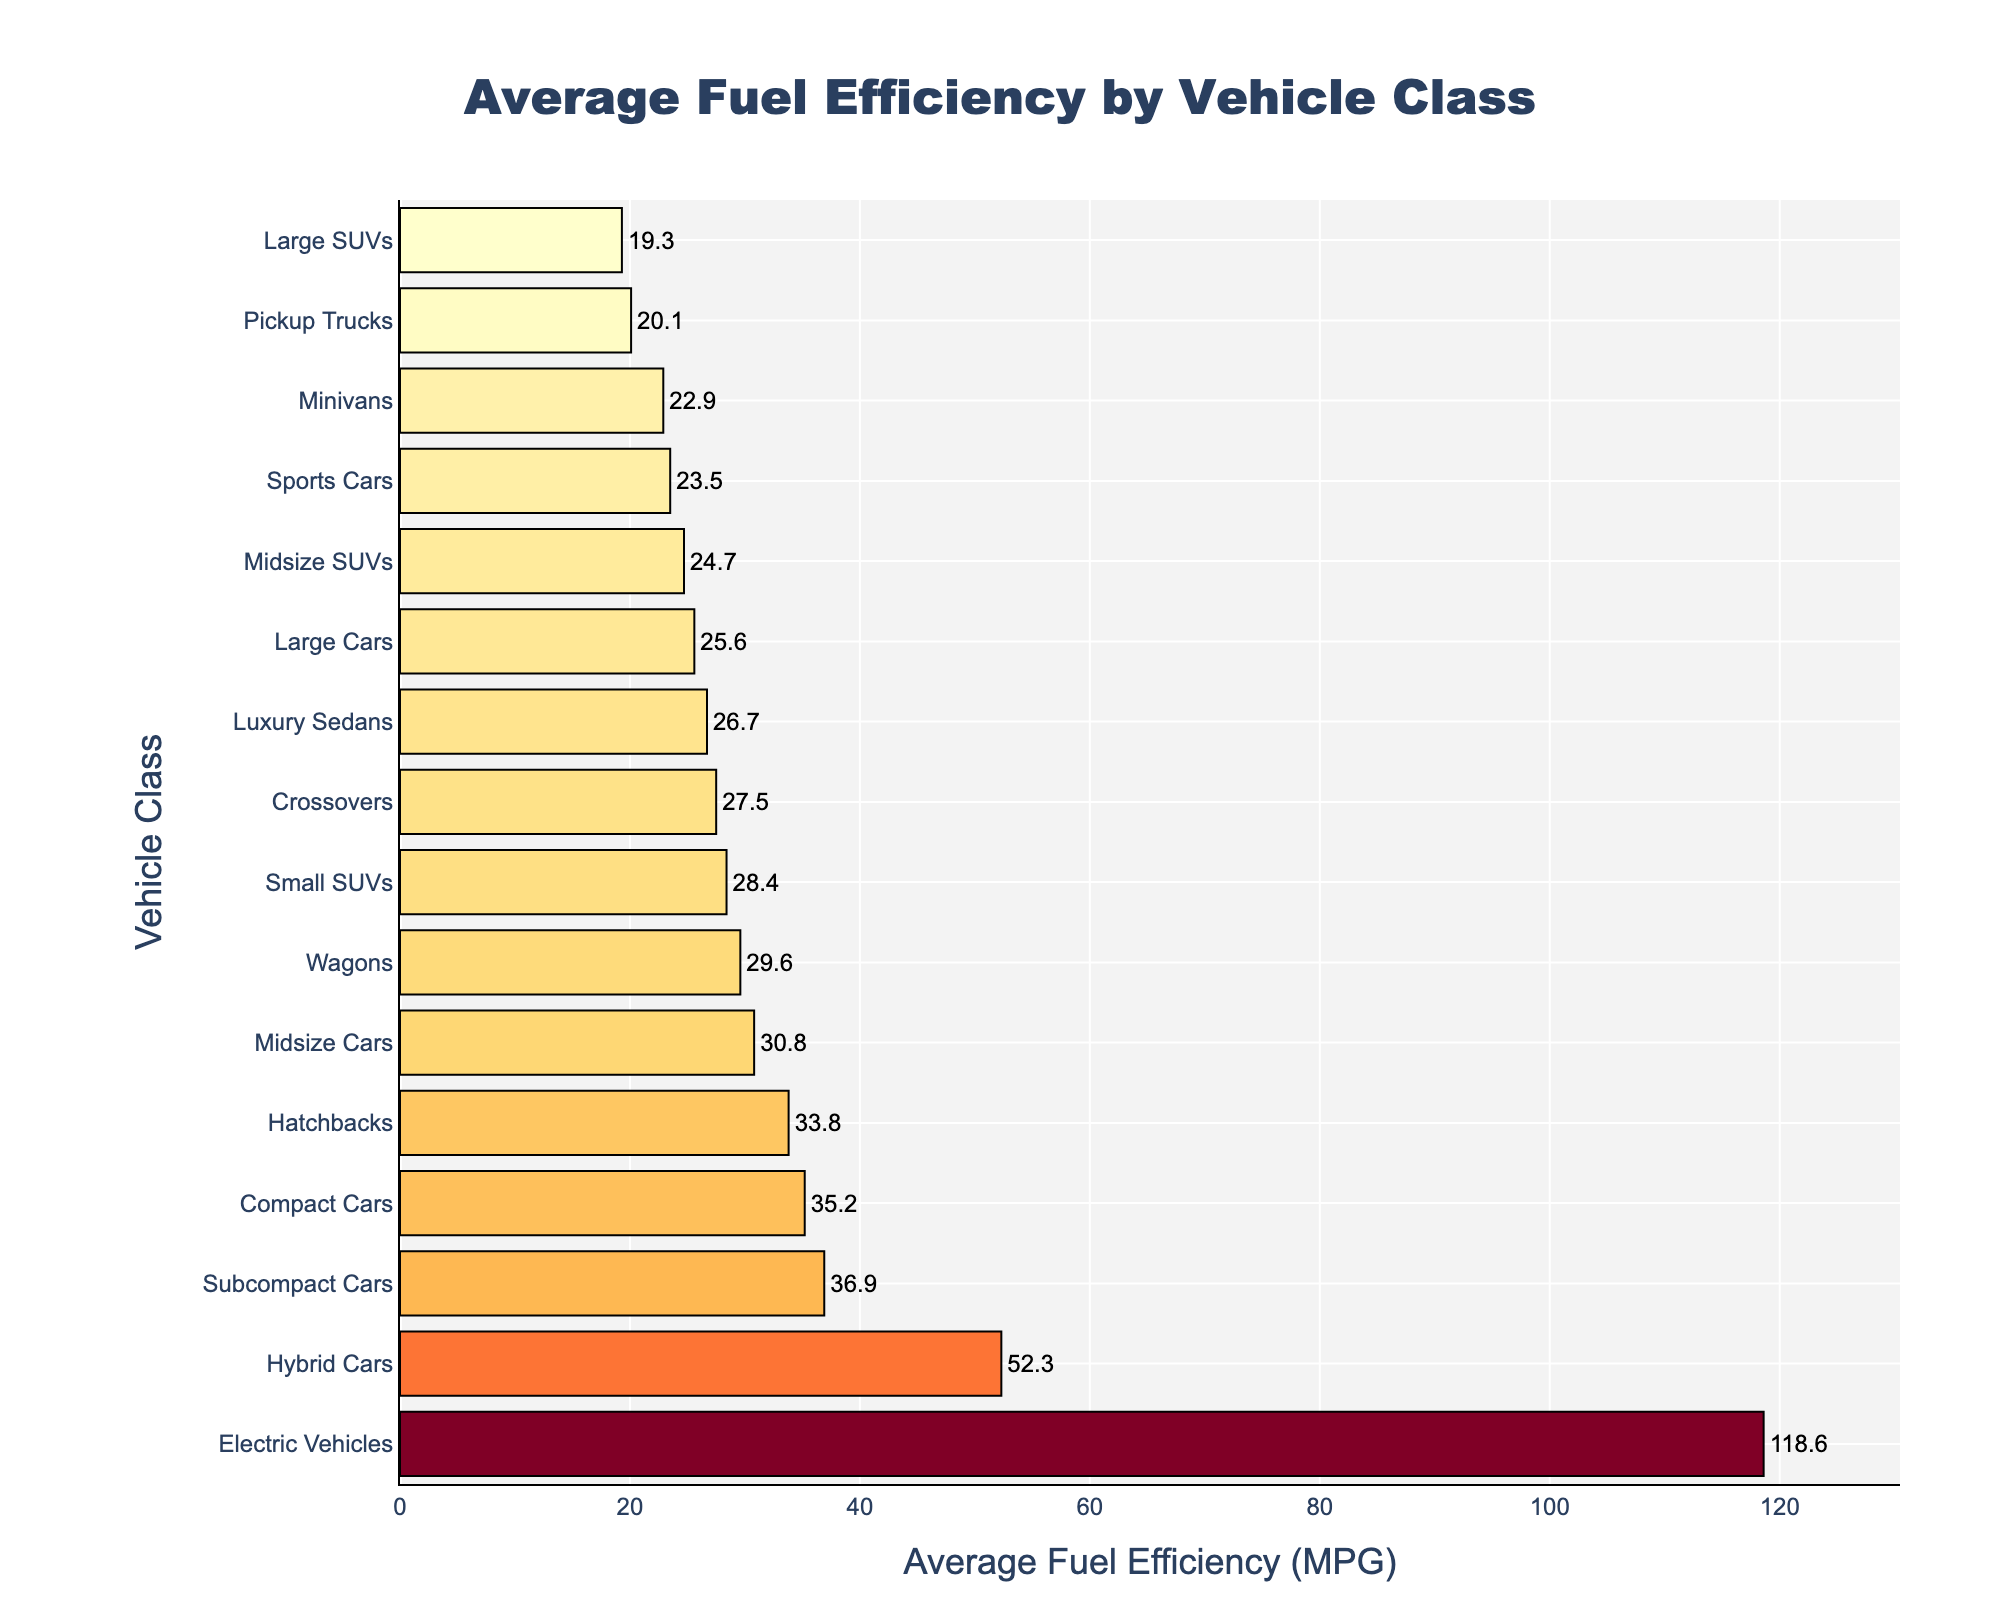Which vehicle class has the highest average fuel efficiency? The highest bar in the figure corresponds to Electric Vehicles, which visually represent the highest fuel efficiency.
Answer: Electric Vehicles How much more fuel-efficient are Compact Cars compared to Pickup Trucks? The bar lengths show Compact Cars at 35.2 MPG and Pickup Trucks at 20.1 MPG. The difference is 35.2 - 20.1 = 15.1 MPG.
Answer: 15.1 MPG Which has better fuel efficiency: Midsize Cars or Small SUVs? Comparing the bar lengths for Midsize Cars (30.8 MPG) and Small SUVs (28.4 MPG), Midsize Cars have better fuel efficiency.
Answer: Midsize Cars What is the average fuel efficiency for the classes with lower efficiency than Crossovers? The bars below Crossovers (27.5 MPG) are for Midsize SUVs (24.7 MPG), Large SUVs (19.3 MPG), Minivans (22.9 MPG), Pickup Trucks (20.1 MPG), and Sports Cars (23.5 MPG). Calculate the average: (24.7 + 19.3 + 22.9 + 20.1 + 23.5) / 5 = 22.1 MPG.
Answer: 22.1 MPG Are Luxury Sedans more fuel-efficient than Large Cars? The bar for Luxury Sedans (26.7 MPG) is higher than the bar for Large Cars (25.6 MPG), indicating better fuel efficiency.
Answer: Yes How many vehicle classes have an average fuel efficiency above 30 MPG? The bars above 30 MPG correspond to Compact Cars, Subcompact Cars, Hatchbacks, Hybrid Cars, and Electric Vehicles, totaling 5 classes.
Answer: 5 What's the difference in fuel efficiency between the most and least fuel-efficient vehicle classes? The highest bar (Electric Vehicles) is 118.6 MPG and the lowest bar (Large SUVs) is 19.3 MPG. The difference is 118.6 - 19.3 = 99.3 MPG.
Answer: 99.3 MPG Which vehicle classes are grouped close together by average fuel efficiency? The bars for Midsize SUVs (24.7 MPG), Minivans (22.9 MPG), and Sports Cars (23.5 MPG) are adjacent, showing similar fuel efficiencies.
Answer: Midsize SUVs, Minivans, Sports Cars What is the combined fuel efficiency of Subcompact Cars and Small SUVs? Subcompact Cars are 36.9 MPG and Small SUVs are 28.4 MPG. The sum is 36.9 + 28.4 = 65.3 MPG.
Answer: 65.3 MPG Do Hybrid Cars have more than twice the fuel efficiency of Large Cars? Hybrid Cars have 52.3 MPG and Large Cars have 25.6 MPG. Twice 25.6 is 51.2, so 52.3 > 51.2.
Answer: Yes 